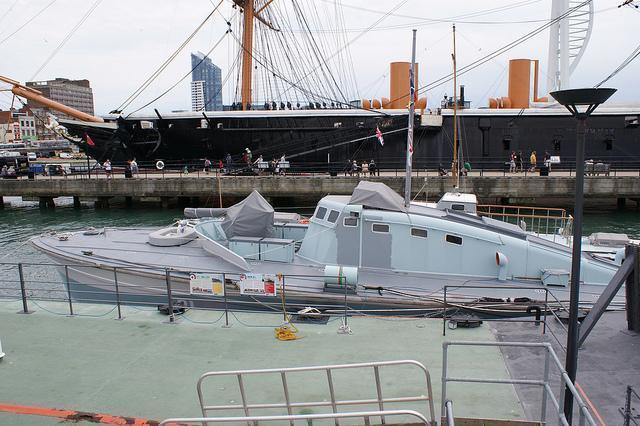How many ships are seen?
Give a very brief answer. 2. How many boats are there?
Give a very brief answer. 2. How many people are in the photo?
Give a very brief answer. 1. 